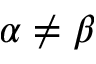<formula> <loc_0><loc_0><loc_500><loc_500>\alpha \neq \beta</formula> 